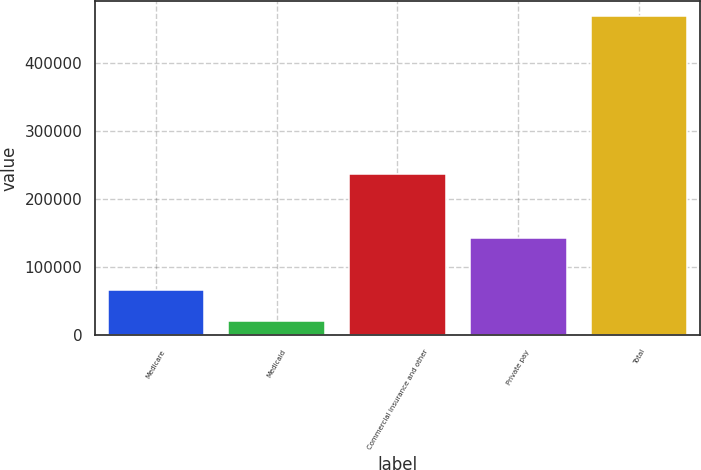Convert chart. <chart><loc_0><loc_0><loc_500><loc_500><bar_chart><fcel>Medicare<fcel>Medicaid<fcel>Commercial insurance and other<fcel>Private pay<fcel>Total<nl><fcel>66125<fcel>20710<fcel>237587<fcel>143683<fcel>468105<nl></chart> 